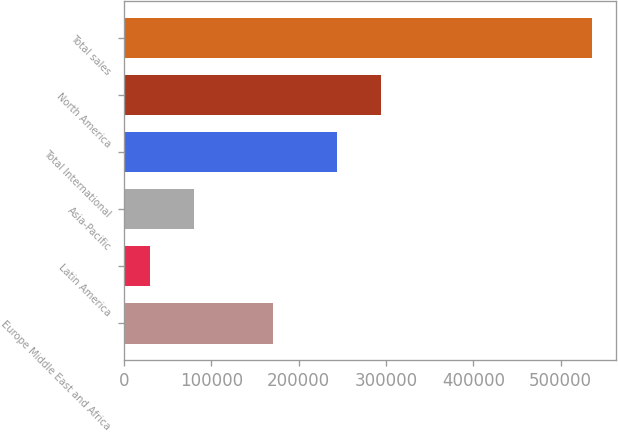Convert chart to OTSL. <chart><loc_0><loc_0><loc_500><loc_500><bar_chart><fcel>Europe Middle East and Africa<fcel>Latin America<fcel>Asia-Pacific<fcel>Total International<fcel>North America<fcel>Total sales<nl><fcel>170544<fcel>29406<fcel>80105.1<fcel>243854<fcel>294553<fcel>536397<nl></chart> 